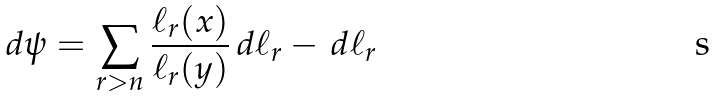Convert formula to latex. <formula><loc_0><loc_0><loc_500><loc_500>d \psi = \sum _ { r > n } \frac { \ell _ { r } ( x ) } { \ell _ { r } ( y ) } \, d \ell _ { r } - \, d \ell _ { r }</formula> 